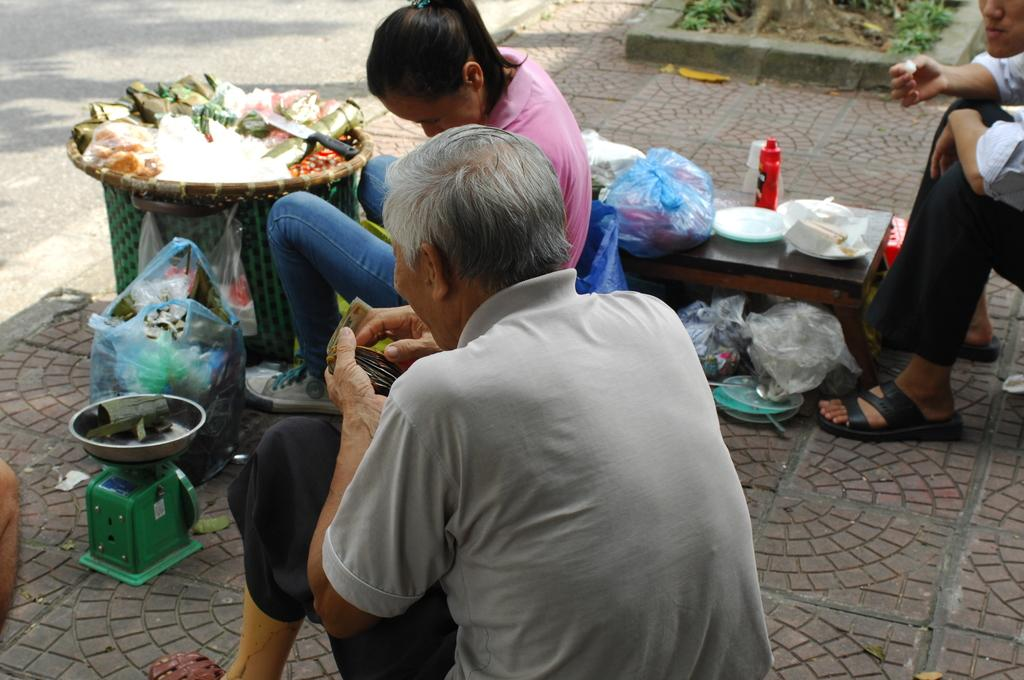How many persons are present in the image? There are three persons in the image. What objects can be seen in the image besides the people? There is a basket, a bowl, a knife, plastic covers, food items, bottles, plates, spoons, and a table in the image. Can you describe the setting where the people are located? The people are located near a table, and there is a road visible in the image. What type of oil is being used to cook the food in the image? There is no cooking activity visible in the image. How much sugar is being used to sweeten the food in the image? There is no visible activity involving sugar in the image. --- Facts: 1. There is a car in the image. 12. The car is red. 13. There are people inside the car. 14. The car has four wheels. 15. The car has a sunroof. 16. The car is parked on the side of the road. Absurd Topics: moon Conversation: What type of vehicle is present in the image? There is a car in the image. What is the color of the car? The car is red. Are there any people inside the car? Yes, there are people inside the car. How many wheels does the car have? The car has four wheels. Does the car have any special features? Yes, the car has a sunroof. Where is the car located in the image? The car is parked on the side of the road. Reasoning: Let's think step by step in order to produce the conversation. We start by identifying the main subject of the image, which is the car. Next, we describe specific features of the car, such as its color, the presence of people inside the car, the number of wheels, and any special features like the sunroof. Then, we observe the location of the car in the image, which is parked on the side of the road. Absurd Question/Answer: Can you see the moon in the image? No, the moon is not present in the image. 